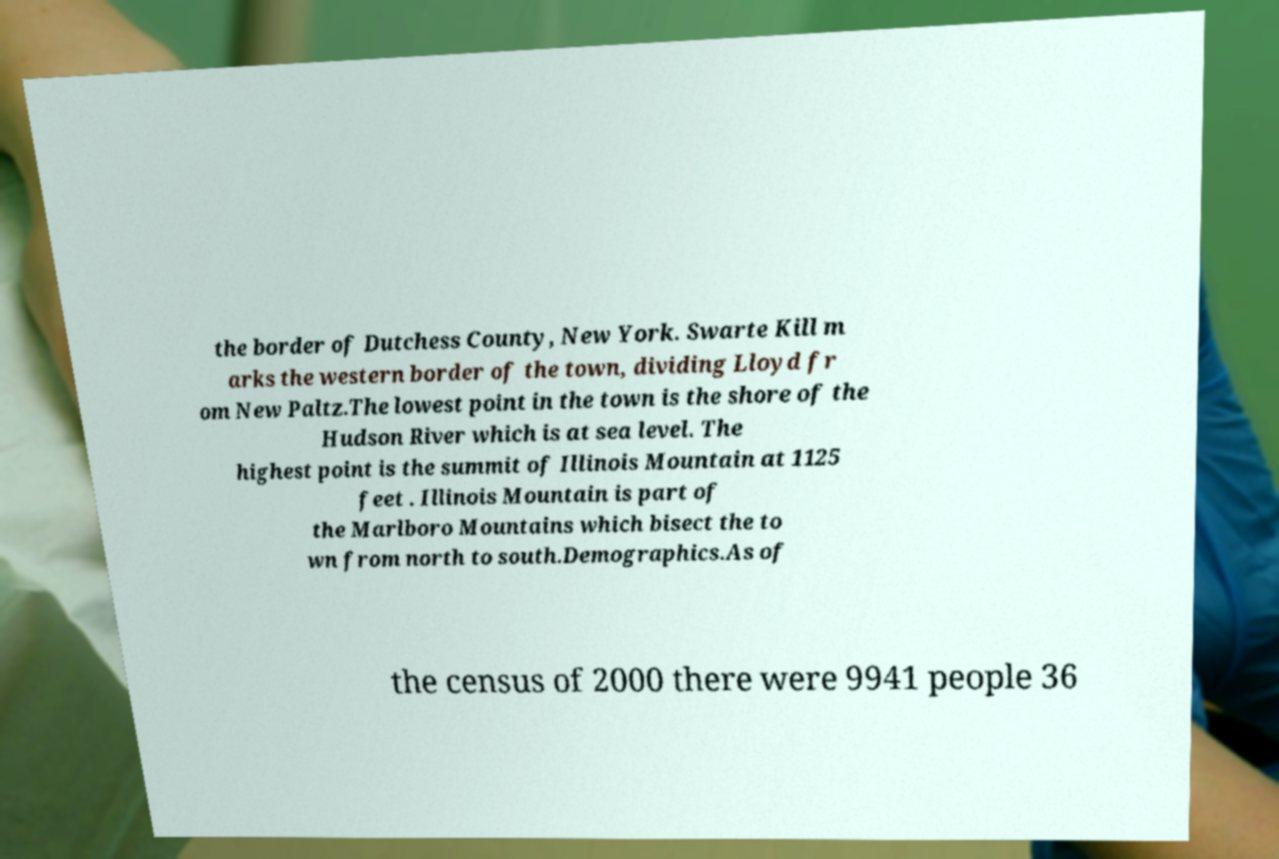Could you assist in decoding the text presented in this image and type it out clearly? the border of Dutchess County, New York. Swarte Kill m arks the western border of the town, dividing Lloyd fr om New Paltz.The lowest point in the town is the shore of the Hudson River which is at sea level. The highest point is the summit of Illinois Mountain at 1125 feet . Illinois Mountain is part of the Marlboro Mountains which bisect the to wn from north to south.Demographics.As of the census of 2000 there were 9941 people 36 